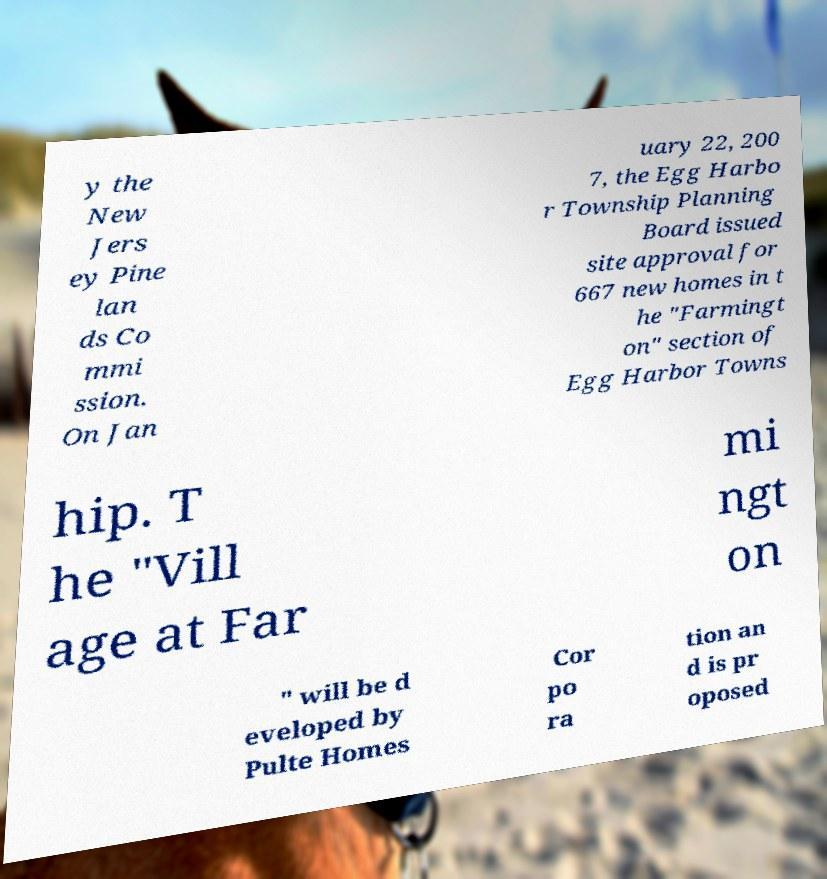Can you read and provide the text displayed in the image?This photo seems to have some interesting text. Can you extract and type it out for me? y the New Jers ey Pine lan ds Co mmi ssion. On Jan uary 22, 200 7, the Egg Harbo r Township Planning Board issued site approval for 667 new homes in t he "Farmingt on" section of Egg Harbor Towns hip. T he "Vill age at Far mi ngt on " will be d eveloped by Pulte Homes Cor po ra tion an d is pr oposed 